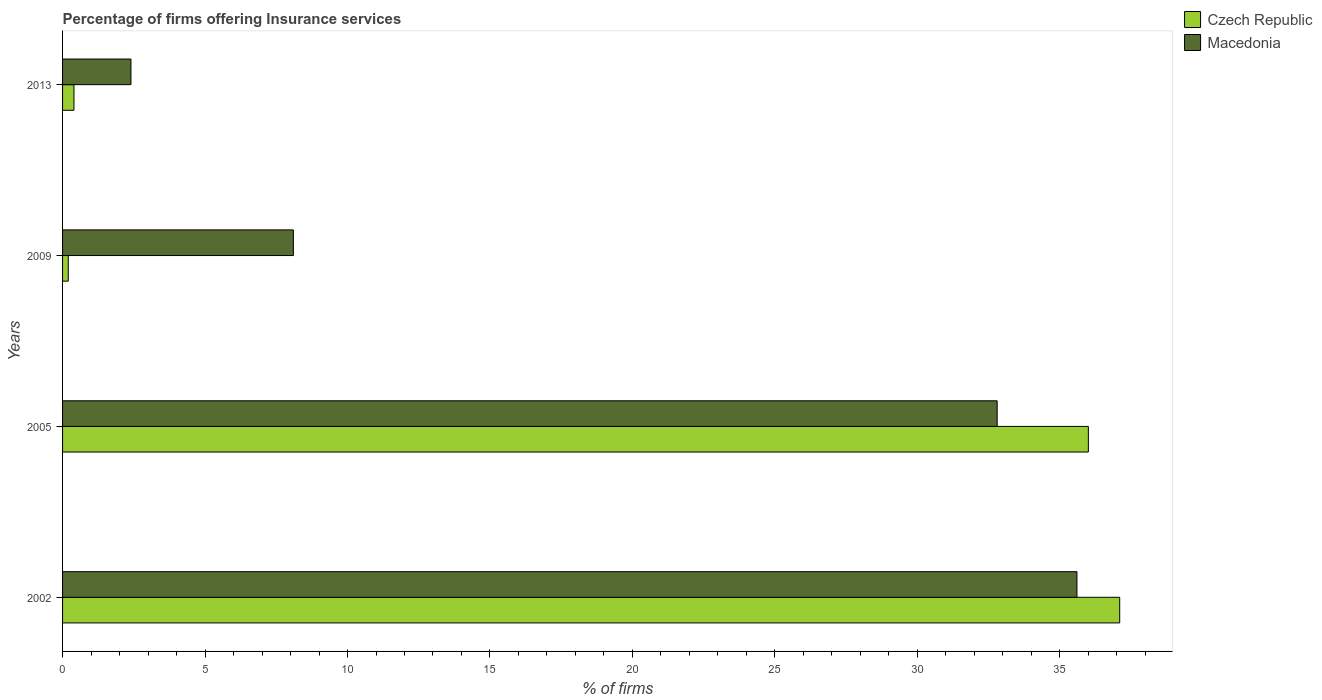How many different coloured bars are there?
Make the answer very short. 2. How many groups of bars are there?
Provide a short and direct response. 4. Are the number of bars per tick equal to the number of legend labels?
Provide a succinct answer. Yes. How many bars are there on the 3rd tick from the bottom?
Ensure brevity in your answer.  2. In how many cases, is the number of bars for a given year not equal to the number of legend labels?
Make the answer very short. 0. What is the percentage of firms offering insurance services in Czech Republic in 2009?
Provide a succinct answer. 0.2. Across all years, what is the maximum percentage of firms offering insurance services in Macedonia?
Keep it short and to the point. 35.6. In which year was the percentage of firms offering insurance services in Czech Republic minimum?
Keep it short and to the point. 2009. What is the total percentage of firms offering insurance services in Macedonia in the graph?
Offer a very short reply. 78.9. What is the difference between the percentage of firms offering insurance services in Macedonia in 2002 and that in 2013?
Provide a succinct answer. 33.2. What is the difference between the percentage of firms offering insurance services in Czech Republic in 2005 and the percentage of firms offering insurance services in Macedonia in 2002?
Offer a terse response. 0.4. What is the average percentage of firms offering insurance services in Czech Republic per year?
Offer a very short reply. 18.43. In how many years, is the percentage of firms offering insurance services in Czech Republic greater than 7 %?
Offer a very short reply. 2. What is the ratio of the percentage of firms offering insurance services in Macedonia in 2002 to that in 2005?
Ensure brevity in your answer.  1.09. What is the difference between the highest and the second highest percentage of firms offering insurance services in Macedonia?
Provide a succinct answer. 2.8. What is the difference between the highest and the lowest percentage of firms offering insurance services in Macedonia?
Keep it short and to the point. 33.2. Is the sum of the percentage of firms offering insurance services in Czech Republic in 2005 and 2009 greater than the maximum percentage of firms offering insurance services in Macedonia across all years?
Ensure brevity in your answer.  Yes. What does the 1st bar from the top in 2005 represents?
Make the answer very short. Macedonia. What does the 1st bar from the bottom in 2005 represents?
Your answer should be very brief. Czech Republic. What is the difference between two consecutive major ticks on the X-axis?
Make the answer very short. 5. Does the graph contain any zero values?
Keep it short and to the point. No. Does the graph contain grids?
Ensure brevity in your answer.  No. Where does the legend appear in the graph?
Your answer should be compact. Top right. How many legend labels are there?
Your answer should be compact. 2. How are the legend labels stacked?
Offer a terse response. Vertical. What is the title of the graph?
Give a very brief answer. Percentage of firms offering Insurance services. What is the label or title of the X-axis?
Your response must be concise. % of firms. What is the label or title of the Y-axis?
Give a very brief answer. Years. What is the % of firms in Czech Republic in 2002?
Your answer should be compact. 37.1. What is the % of firms in Macedonia in 2002?
Keep it short and to the point. 35.6. What is the % of firms in Czech Republic in 2005?
Your answer should be compact. 36. What is the % of firms in Macedonia in 2005?
Give a very brief answer. 32.8. What is the % of firms of Macedonia in 2009?
Provide a short and direct response. 8.1. What is the % of firms of Czech Republic in 2013?
Provide a short and direct response. 0.4. Across all years, what is the maximum % of firms in Czech Republic?
Make the answer very short. 37.1. Across all years, what is the maximum % of firms in Macedonia?
Offer a terse response. 35.6. What is the total % of firms of Czech Republic in the graph?
Give a very brief answer. 73.7. What is the total % of firms of Macedonia in the graph?
Your answer should be compact. 78.9. What is the difference between the % of firms in Czech Republic in 2002 and that in 2005?
Your answer should be very brief. 1.1. What is the difference between the % of firms in Macedonia in 2002 and that in 2005?
Keep it short and to the point. 2.8. What is the difference between the % of firms of Czech Republic in 2002 and that in 2009?
Your answer should be compact. 36.9. What is the difference between the % of firms in Czech Republic in 2002 and that in 2013?
Offer a terse response. 36.7. What is the difference between the % of firms in Macedonia in 2002 and that in 2013?
Your answer should be very brief. 33.2. What is the difference between the % of firms in Czech Republic in 2005 and that in 2009?
Make the answer very short. 35.8. What is the difference between the % of firms in Macedonia in 2005 and that in 2009?
Provide a short and direct response. 24.7. What is the difference between the % of firms of Czech Republic in 2005 and that in 2013?
Ensure brevity in your answer.  35.6. What is the difference between the % of firms of Macedonia in 2005 and that in 2013?
Ensure brevity in your answer.  30.4. What is the difference between the % of firms of Czech Republic in 2009 and that in 2013?
Your answer should be compact. -0.2. What is the difference between the % of firms of Macedonia in 2009 and that in 2013?
Keep it short and to the point. 5.7. What is the difference between the % of firms of Czech Republic in 2002 and the % of firms of Macedonia in 2013?
Your response must be concise. 34.7. What is the difference between the % of firms in Czech Republic in 2005 and the % of firms in Macedonia in 2009?
Offer a very short reply. 27.9. What is the difference between the % of firms of Czech Republic in 2005 and the % of firms of Macedonia in 2013?
Give a very brief answer. 33.6. What is the difference between the % of firms of Czech Republic in 2009 and the % of firms of Macedonia in 2013?
Offer a terse response. -2.2. What is the average % of firms of Czech Republic per year?
Offer a very short reply. 18.43. What is the average % of firms in Macedonia per year?
Keep it short and to the point. 19.73. What is the ratio of the % of firms of Czech Republic in 2002 to that in 2005?
Your answer should be very brief. 1.03. What is the ratio of the % of firms of Macedonia in 2002 to that in 2005?
Make the answer very short. 1.09. What is the ratio of the % of firms of Czech Republic in 2002 to that in 2009?
Your answer should be compact. 185.5. What is the ratio of the % of firms of Macedonia in 2002 to that in 2009?
Keep it short and to the point. 4.4. What is the ratio of the % of firms of Czech Republic in 2002 to that in 2013?
Ensure brevity in your answer.  92.75. What is the ratio of the % of firms in Macedonia in 2002 to that in 2013?
Provide a short and direct response. 14.83. What is the ratio of the % of firms of Czech Republic in 2005 to that in 2009?
Offer a terse response. 180. What is the ratio of the % of firms in Macedonia in 2005 to that in 2009?
Provide a succinct answer. 4.05. What is the ratio of the % of firms in Czech Republic in 2005 to that in 2013?
Keep it short and to the point. 90. What is the ratio of the % of firms of Macedonia in 2005 to that in 2013?
Provide a succinct answer. 13.67. What is the ratio of the % of firms in Czech Republic in 2009 to that in 2013?
Ensure brevity in your answer.  0.5. What is the ratio of the % of firms of Macedonia in 2009 to that in 2013?
Your response must be concise. 3.38. What is the difference between the highest and the lowest % of firms of Czech Republic?
Ensure brevity in your answer.  36.9. What is the difference between the highest and the lowest % of firms of Macedonia?
Your answer should be compact. 33.2. 